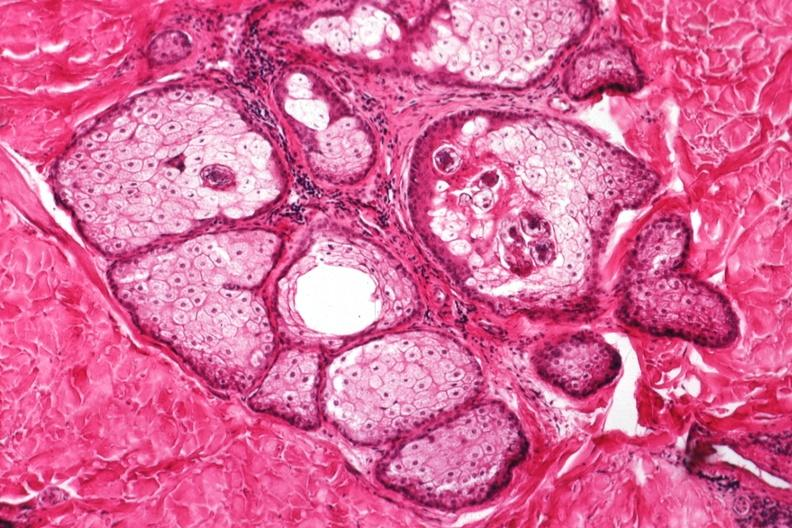where is this?
Answer the question using a single word or phrase. Skin 